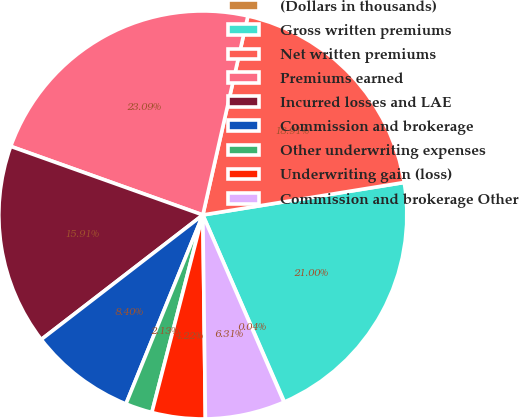Convert chart to OTSL. <chart><loc_0><loc_0><loc_500><loc_500><pie_chart><fcel>(Dollars in thousands)<fcel>Gross written premiums<fcel>Net written premiums<fcel>Premiums earned<fcel>Incurred losses and LAE<fcel>Commission and brokerage<fcel>Other underwriting expenses<fcel>Underwriting gain (loss)<fcel>Commission and brokerage Other<nl><fcel>0.04%<fcel>21.0%<fcel>18.91%<fcel>23.09%<fcel>15.91%<fcel>8.4%<fcel>2.13%<fcel>4.22%<fcel>6.31%<nl></chart> 